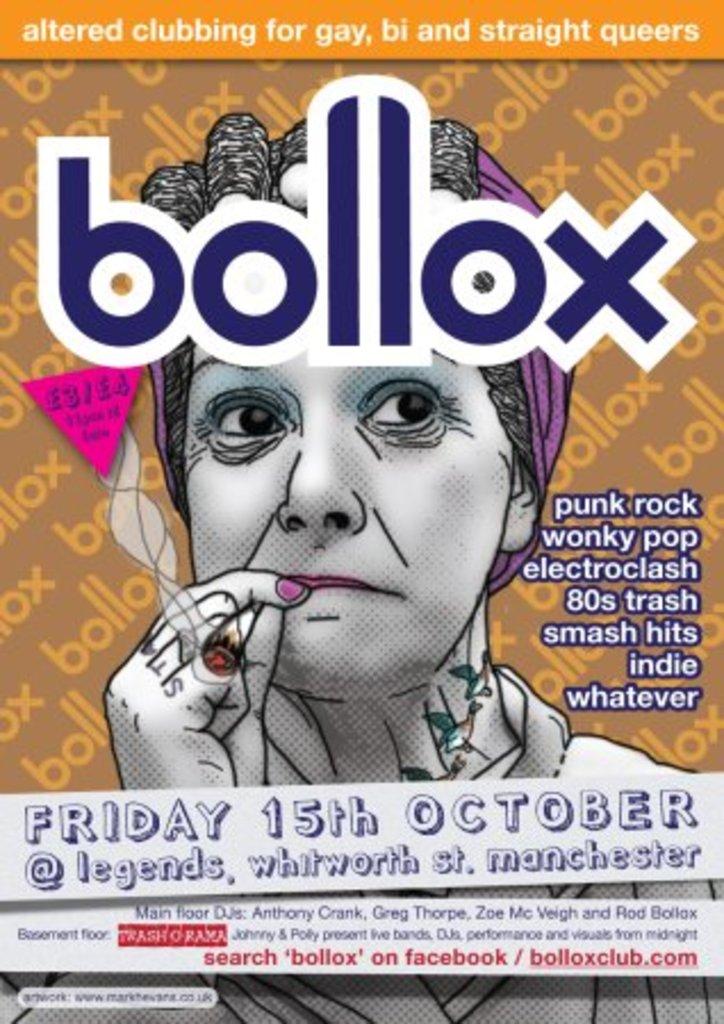When is the event listed on this page?
Provide a short and direct response. Bollox. What is the name of the magazine?
Your response must be concise. Bollox. 